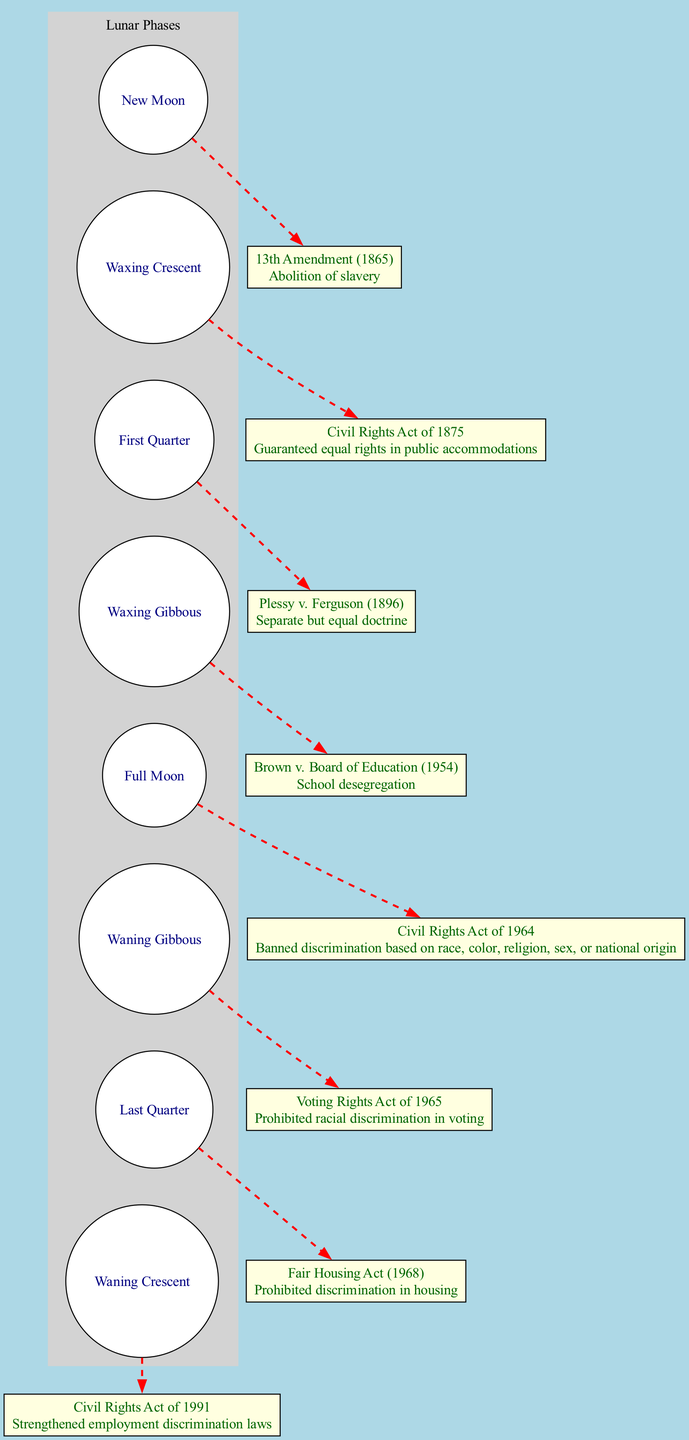What is the event associated with the Full Moon phase? The Full Moon phase is associated with the Civil Rights Act of 1964, which is labeled in the diagram.
Answer: Civil Rights Act of 1964 How many phases are displayed in the lunar phase section? The diagram contains eight distinct lunar phases listed in a circular arrangement, which can be counted for confirmation.
Answer: 8 Which Supreme Court case is linked to the First Quarter phase? The First Quarter phase shows the node connected to Plessy v. Ferguson (1896), indicating its association with this specific phase.
Answer: Plessy v. Ferguson What is the main description for the event in the Waxing Gibbous phase? By locating the Waxing Gibbous phase in the diagram, we see it is linked to Brown v. Board of Education (1954) and its description of school desegregation is provided there.
Answer: School desegregation Which civil rights event follows the Voting Rights Act of 1965 in the diagram? Following the Voting Rights Act of 1965, the next event in the diagram is the Fair Housing Act (1968), indicating a continuation of the civil rights timeline.
Answer: Fair Housing Act (1968) Is any lunar phase associated with a civil rights event concerning employment? The Waxing Crescent phase in the diagram corresponds to the Civil Rights Act of 1991, which specifically addresses employment discrimination, providing this linkage.
Answer: Yes How many civil rights events are displayed in total? Each event is depicted as a box connected to the corresponding lunar phase, and by counting all events within the diagram, we confirm that there are eight total civil rights events.
Answer: 8 What color is used for the lunar phases in the diagram? The lunar phases are represented with white-colored circles filled with a specific color in the diagram, allowing for easy identification.
Answer: White 